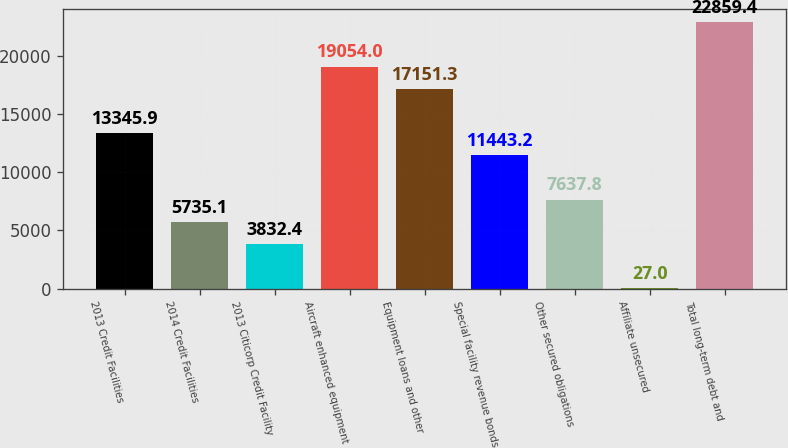<chart> <loc_0><loc_0><loc_500><loc_500><bar_chart><fcel>2013 Credit Facilities<fcel>2014 Credit Facilities<fcel>2013 Citicorp Credit Facility<fcel>Aircraft enhanced equipment<fcel>Equipment loans and other<fcel>Special facility revenue bonds<fcel>Other secured obligations<fcel>Affiliate unsecured<fcel>Total long-term debt and<nl><fcel>13345.9<fcel>5735.1<fcel>3832.4<fcel>19054<fcel>17151.3<fcel>11443.2<fcel>7637.8<fcel>27<fcel>22859.4<nl></chart> 